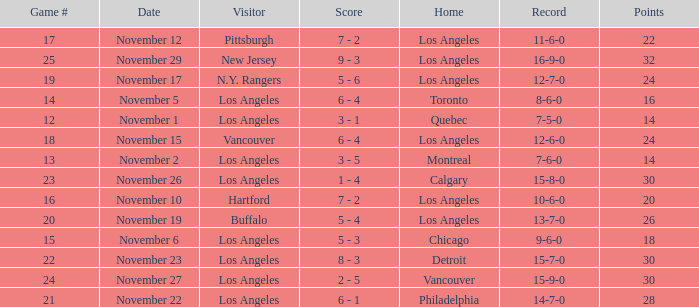Who is the visitor team of game 19 with Los Angeles as the home team? N.Y. Rangers. 